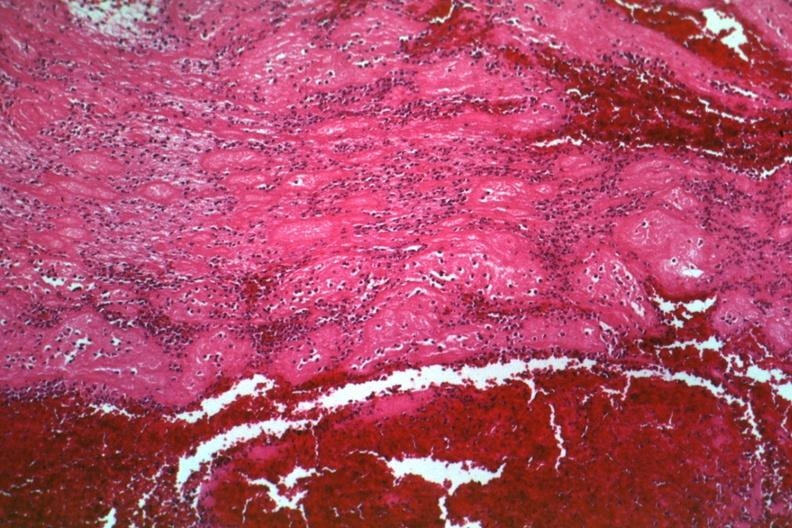s hematologic present?
Answer the question using a single word or phrase. Yes 